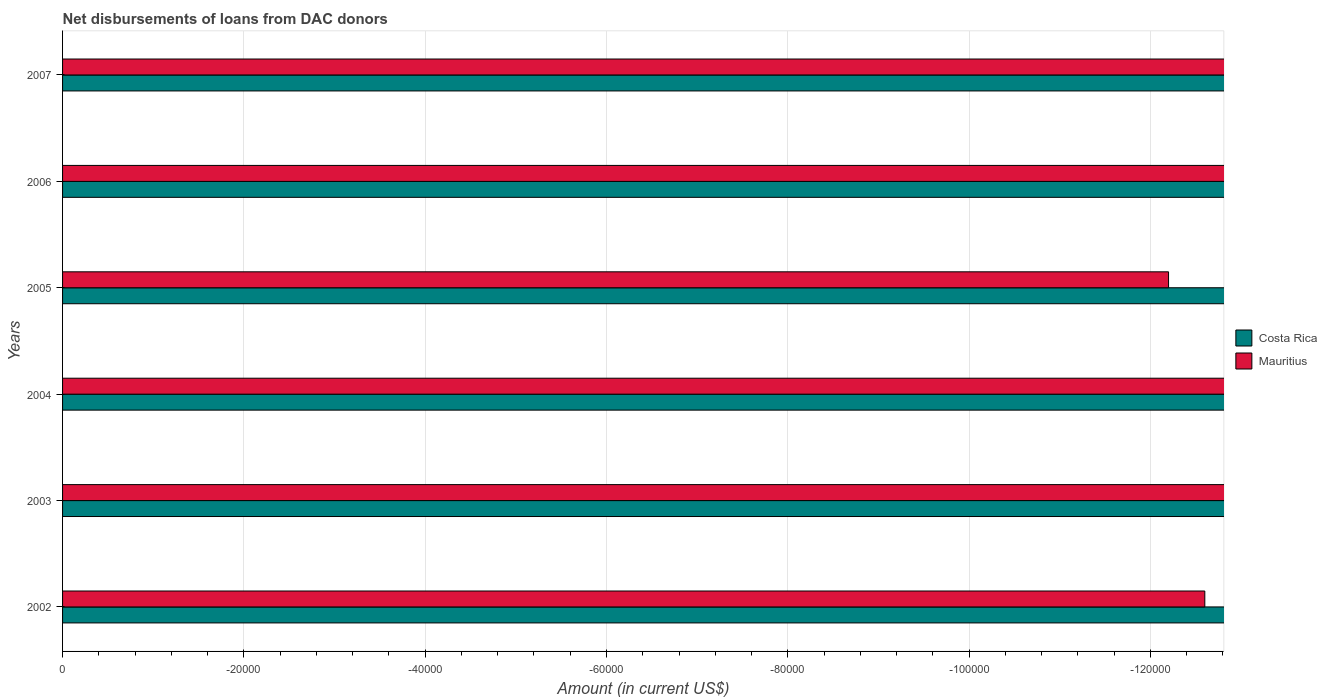How many bars are there on the 6th tick from the top?
Provide a short and direct response. 0. How many bars are there on the 4th tick from the bottom?
Your answer should be very brief. 0. What is the label of the 2nd group of bars from the top?
Your response must be concise. 2006. In how many cases, is the number of bars for a given year not equal to the number of legend labels?
Provide a short and direct response. 6. Across all years, what is the minimum amount of loans disbursed in Mauritius?
Give a very brief answer. 0. How many years are there in the graph?
Offer a terse response. 6. What is the difference between two consecutive major ticks on the X-axis?
Offer a very short reply. 2.00e+04. Are the values on the major ticks of X-axis written in scientific E-notation?
Keep it short and to the point. No. Does the graph contain any zero values?
Provide a short and direct response. Yes. Does the graph contain grids?
Give a very brief answer. Yes. Where does the legend appear in the graph?
Your answer should be compact. Center right. How many legend labels are there?
Offer a terse response. 2. How are the legend labels stacked?
Ensure brevity in your answer.  Vertical. What is the title of the graph?
Provide a succinct answer. Net disbursements of loans from DAC donors. What is the label or title of the X-axis?
Your answer should be compact. Amount (in current US$). What is the label or title of the Y-axis?
Offer a very short reply. Years. What is the Amount (in current US$) of Costa Rica in 2002?
Offer a very short reply. 0. What is the Amount (in current US$) in Mauritius in 2003?
Provide a succinct answer. 0. What is the Amount (in current US$) in Costa Rica in 2004?
Offer a very short reply. 0. What is the Amount (in current US$) in Mauritius in 2004?
Provide a succinct answer. 0. What is the Amount (in current US$) of Costa Rica in 2005?
Provide a short and direct response. 0. What is the Amount (in current US$) in Costa Rica in 2007?
Offer a terse response. 0. What is the average Amount (in current US$) of Costa Rica per year?
Your response must be concise. 0. 